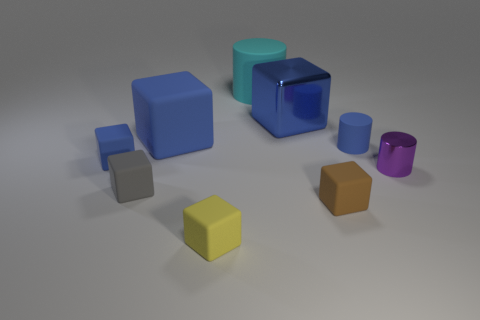Add 1 tiny brown cubes. How many objects exist? 10 Subtract all matte cylinders. How many cylinders are left? 1 Subtract all red spheres. How many blue blocks are left? 3 Subtract 2 blocks. How many blocks are left? 4 Subtract all brown blocks. How many blocks are left? 5 Subtract all cylinders. How many objects are left? 6 Add 8 purple metallic things. How many purple metallic things are left? 9 Add 5 small brown rubber blocks. How many small brown rubber blocks exist? 6 Subtract 1 cyan cylinders. How many objects are left? 8 Subtract all brown cylinders. Subtract all yellow blocks. How many cylinders are left? 3 